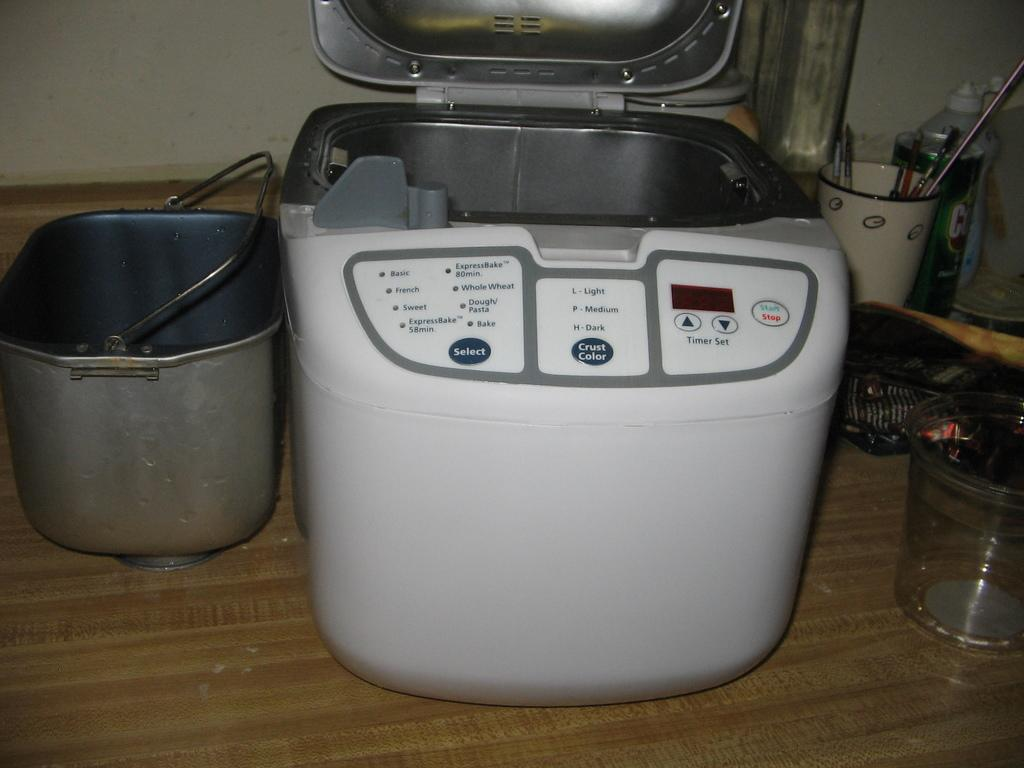Provide a one-sentence caption for the provided image. A picture of a bread machine with several settings including Basic, French and Sweet. 